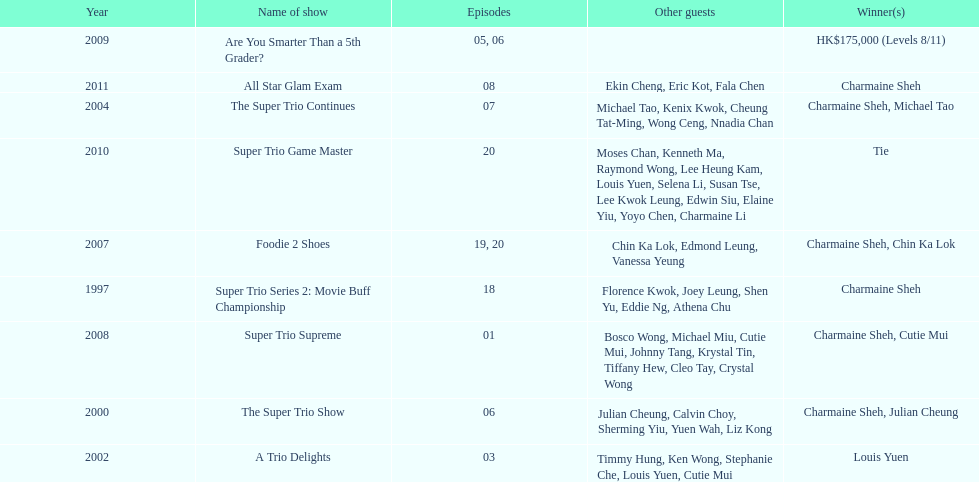How many times has charmaine sheh won on a variety show? 6. 